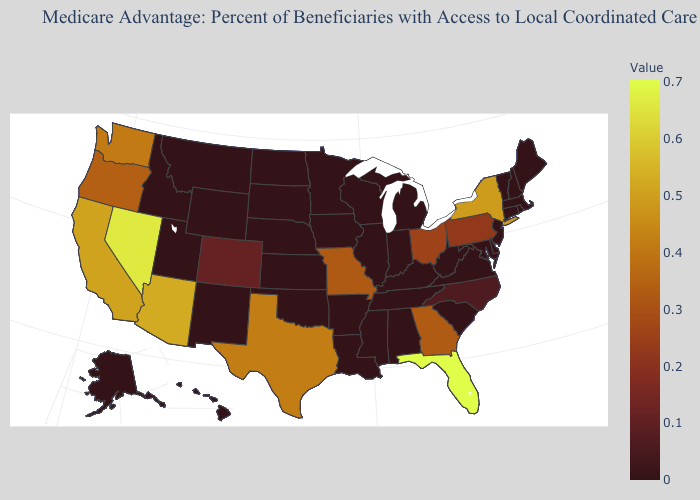Which states have the highest value in the USA?
Answer briefly. Florida. Which states have the lowest value in the West?
Concise answer only. Alaska, Hawaii, Idaho, Montana, New Mexico, Utah, Wyoming. Does the map have missing data?
Be succinct. No. Which states have the lowest value in the USA?
Give a very brief answer. Alaska, Alabama, Arkansas, Connecticut, Delaware, Hawaii, Iowa, Idaho, Illinois, Indiana, Kansas, Kentucky, Louisiana, Massachusetts, Maryland, Maine, Michigan, Minnesota, Mississippi, Montana, North Dakota, Nebraska, New Hampshire, New Jersey, New Mexico, Oklahoma, Rhode Island, South Carolina, South Dakota, Tennessee, Utah, Virginia, Vermont, Wisconsin, West Virginia, Wyoming. 